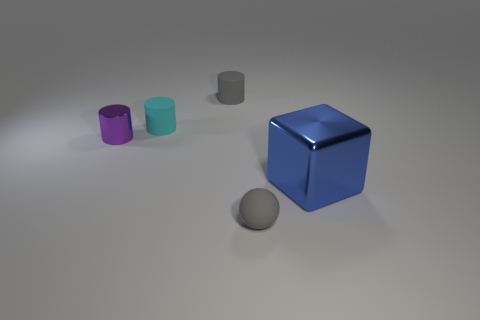Is there any other thing that has the same size as the blue thing?
Your answer should be compact. No. Is there a metal thing left of the gray thing that is behind the shiny object that is left of the large thing?
Give a very brief answer. Yes. Are there fewer cyan cylinders that are in front of the gray cylinder than small things?
Provide a short and direct response. Yes. What number of other objects are the same shape as the small cyan object?
Give a very brief answer. 2. How many things are either small objects that are left of the small cyan cylinder or objects that are to the right of the tiny gray cylinder?
Your answer should be very brief. 3. There is a object that is behind the gray matte ball and in front of the tiny metal thing; what size is it?
Keep it short and to the point. Large. Do the metal thing on the left side of the big blue thing and the large blue thing have the same shape?
Your answer should be compact. No. What size is the shiny object to the right of the small gray thing that is behind the matte thing in front of the blue object?
Your response must be concise. Large. There is a matte cylinder that is the same color as the small matte sphere; what is its size?
Keep it short and to the point. Small. What number of objects are either metallic blocks or small objects?
Offer a terse response. 5. 